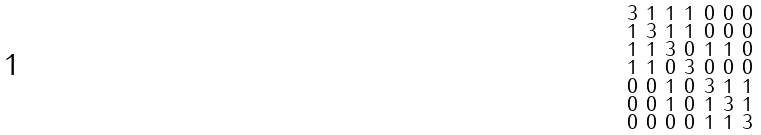Convert formula to latex. <formula><loc_0><loc_0><loc_500><loc_500>\begin{smallmatrix} 3 & 1 & 1 & 1 & 0 & 0 & 0 \\ 1 & 3 & 1 & 1 & 0 & 0 & 0 \\ 1 & 1 & 3 & 0 & 1 & 1 & 0 \\ 1 & 1 & 0 & 3 & 0 & 0 & 0 \\ 0 & 0 & 1 & 0 & 3 & 1 & 1 \\ 0 & 0 & 1 & 0 & 1 & 3 & 1 \\ 0 & 0 & 0 & 0 & 1 & 1 & 3 \end{smallmatrix}</formula> 